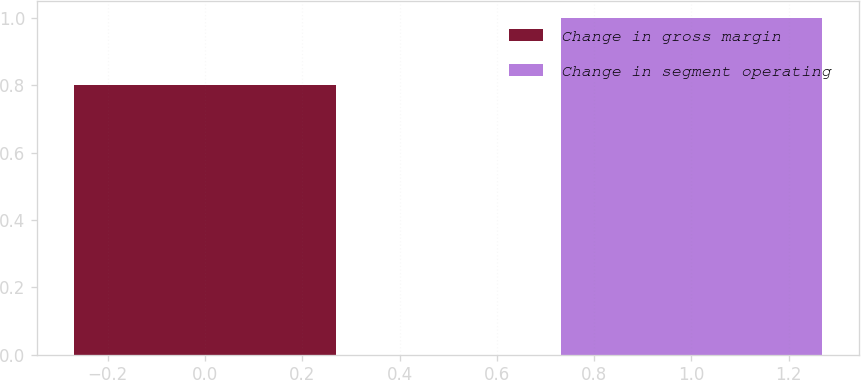<chart> <loc_0><loc_0><loc_500><loc_500><bar_chart><fcel>Change in gross margin<fcel>Change in segment operating<nl><fcel>0.8<fcel>1<nl></chart> 